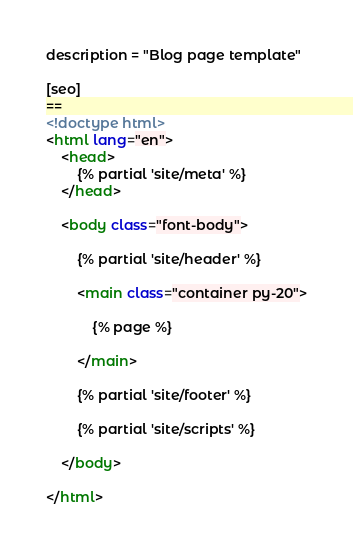<code> <loc_0><loc_0><loc_500><loc_500><_HTML_>description = "Blog page template"

[seo]
==
<!doctype html>
<html lang="en">
    <head>
        {% partial 'site/meta' %}
    </head>

    <body class="font-body">

        {% partial 'site/header' %}

        <main class="container py-20">

            {% page %}

        </main>

        {% partial 'site/footer' %}

        {% partial 'site/scripts' %}

    </body>

</html></code> 